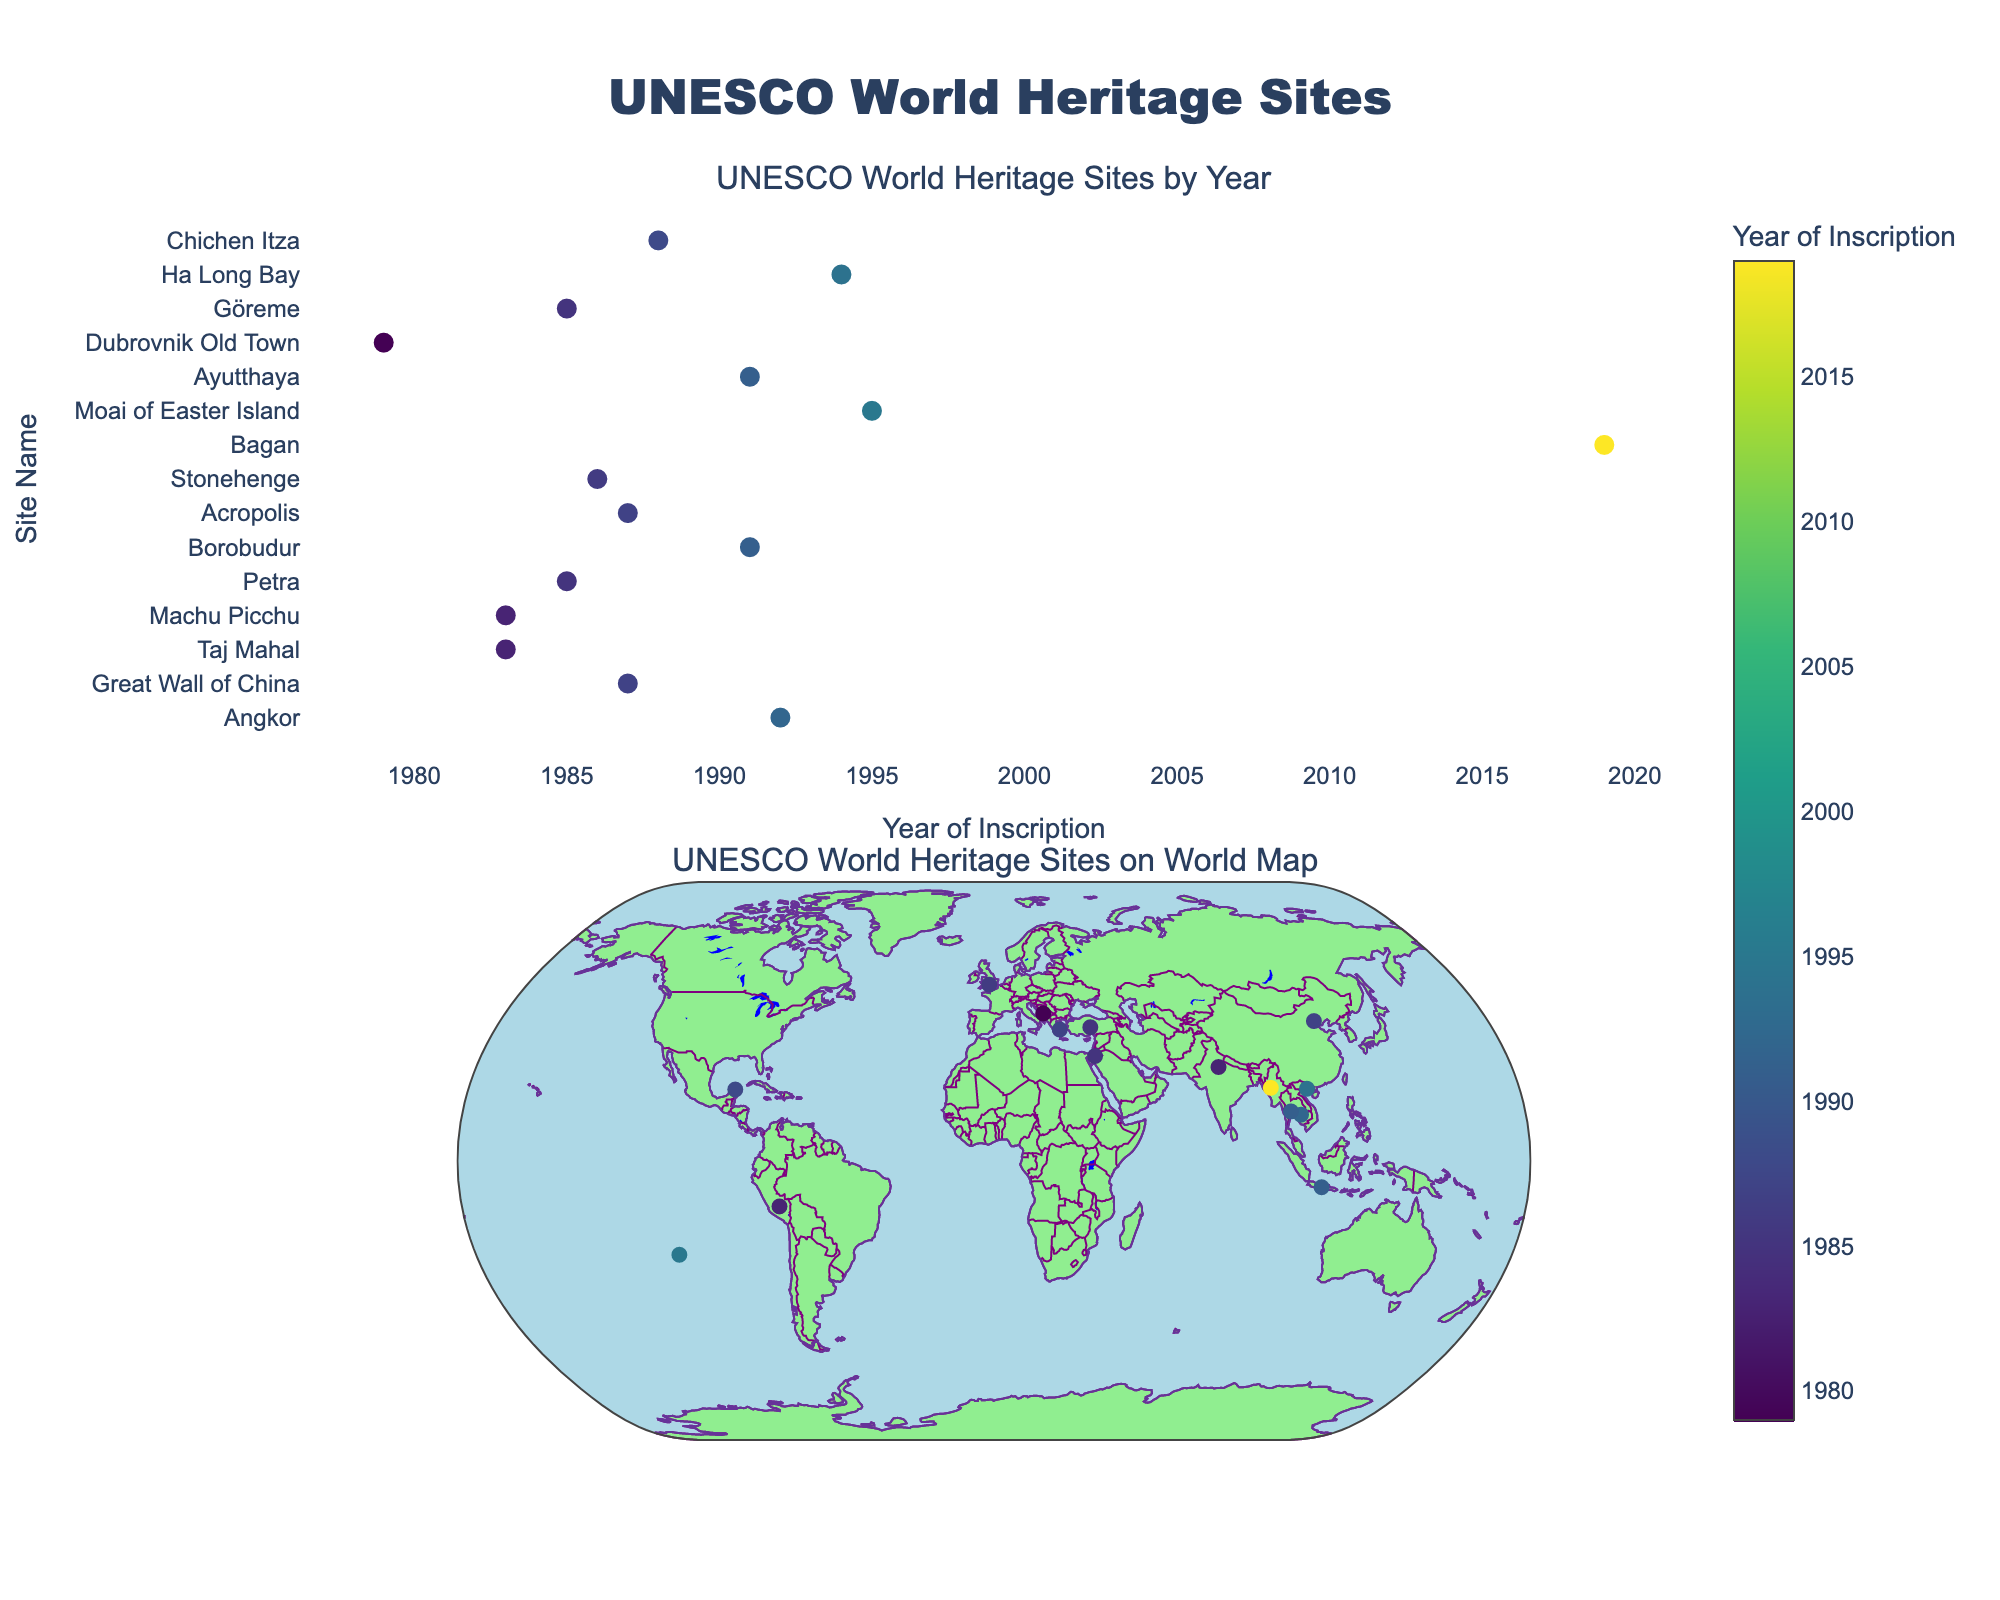What's the title of the figure? The title is prominently displayed at the top of the figure.
Answer: UNESCO World Heritage Sites What do the colors of the markers represent in the scatter plot? The color of the markers is tied to the year of inscription of each site, as indicated by the color bar labeled "Year of Inscription" on the scatter plot.
Answer: Year of Inscription Which site was inscribed as a UNESCO World Heritage Site in 2019? By looking at the scatter plot's x-axis for the year 2019 and checking the corresponding site, you can see that Bagan is inscribed in 2019.
Answer: Bagan Which site appears the furthest west on the world map plot? The Moai of Easter Island is furthest west as it has the westernmost longitude among the plotted sites.
Answer: Moai of Easter Island What is the median year of inscription for all the UNESCO World Heritage Sites shown? To find the median inscription year, first list all the years, then arrange them in ascending order and find the middle value. The list of years is [1979, 1983, 1983, 1985, 1986, 1987, 1987, 1988, 1991, 1991, 1992, 1994, 1995, 2019]. Thus, the median year is the one between 1991 and 1992.
Answer: 1991.5 Which site is inscribed the earliest? By observing the scatter plot and checking the site name associated with the earliest year on the x-axis, we find that Dubrovnik Old Town, which was inscribed in 1979, is the earliest.
Answer: Dubrovnik Old Town How many UNESCO World Heritage Sites were inscribed in the 1980s? Counting the data points in the 1980s, we have the following inscriptions: Taj Mahal (1983), Machu Picchu (1983), Petra (1985), Acropolis (1987), Great Wall of China (1987), Stonehenge (1986), and Chichen Itza (1988), totaling 7 sites.
Answer: 7 Which site is located closest to the equator? By analyzing the latitudes on the world map plot, the site with the latitude closest to zero is Borobudur, at approximately -7.6079.
Answer: Borobudur Which site appears in both the top list by year and on the map with the highest latitude? By looking at the earliest years in the first subplot, and matching it with the highest latitude in the second subplot, we see that the Great Wall of China (40.4319) fits both criteria.
Answer: Great Wall of China 